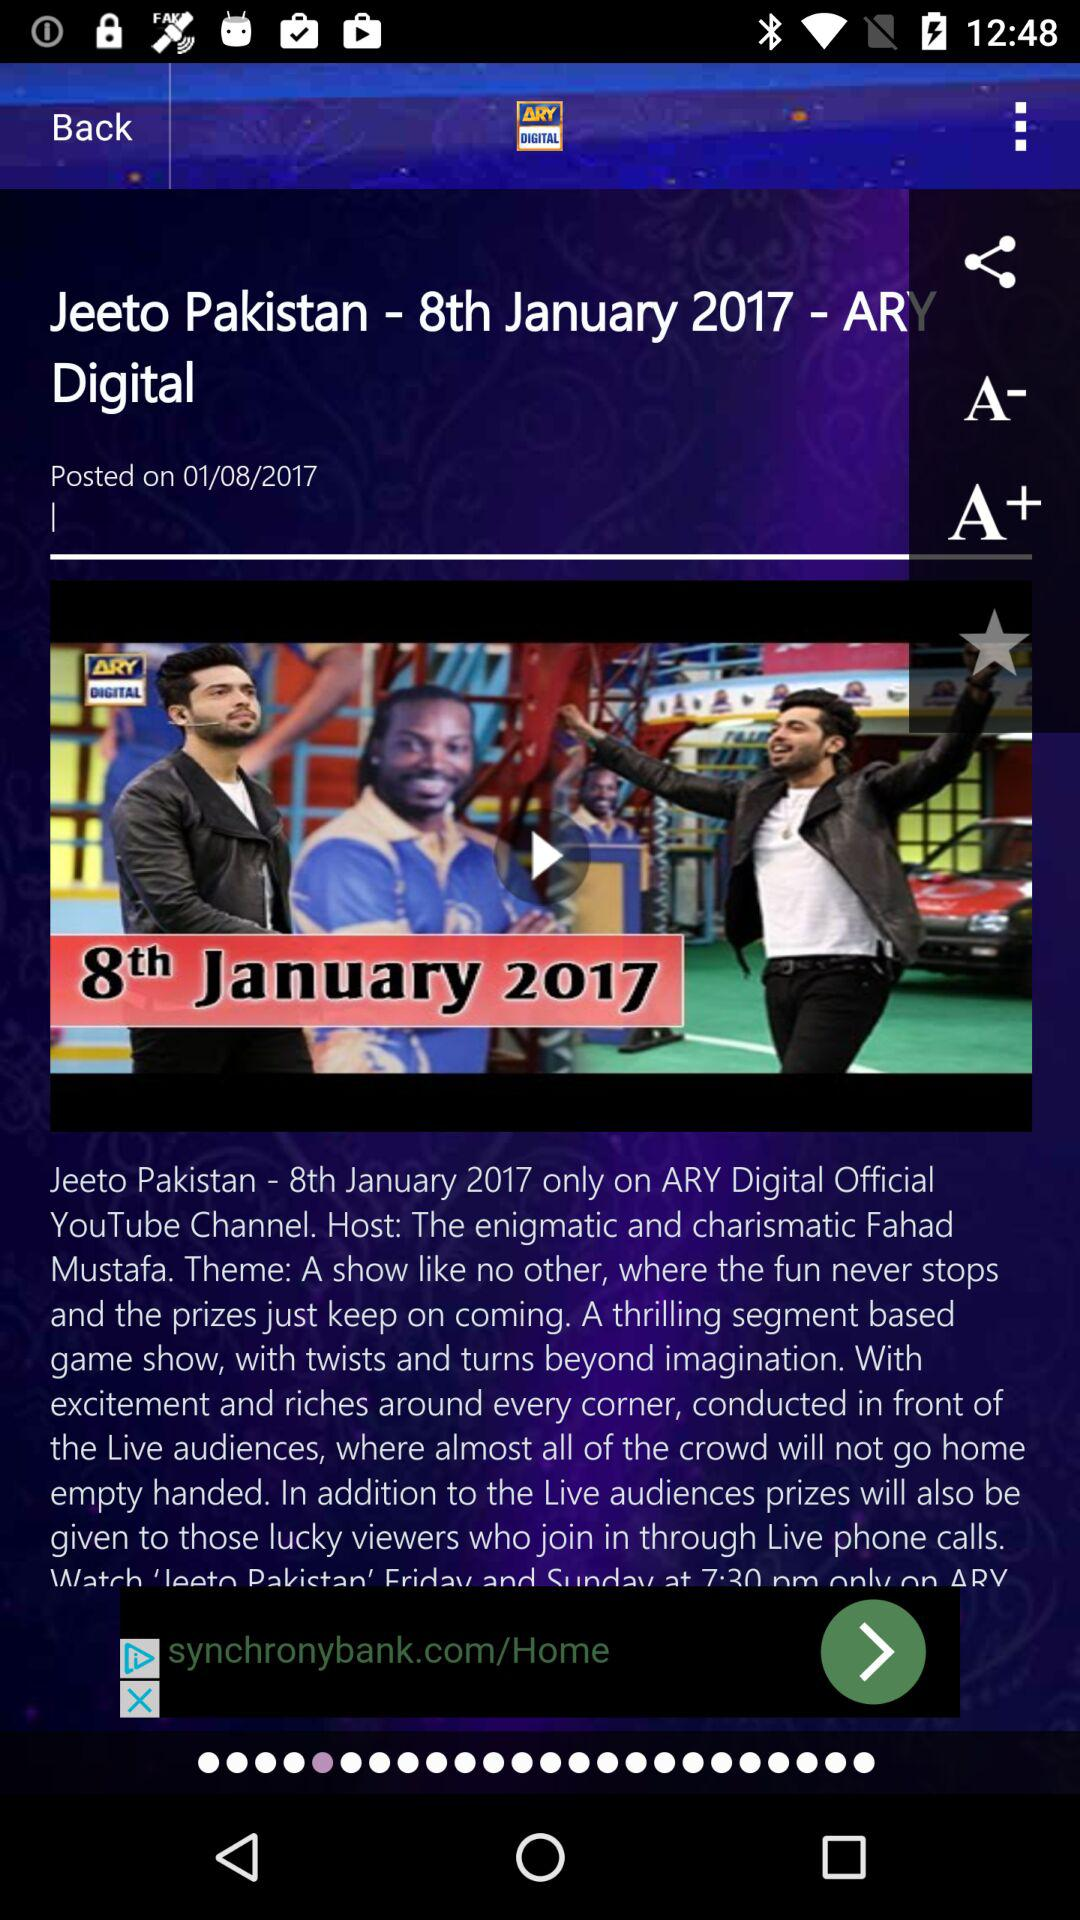What is the show name? The show name is "Jeeto Pakistan - 8th January 2017". 